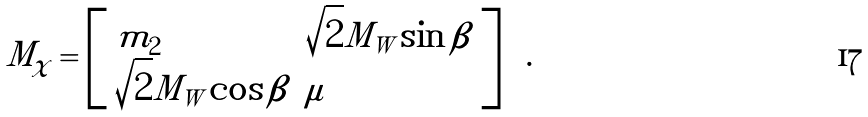<formula> <loc_0><loc_0><loc_500><loc_500>M _ { \chi } = \left [ \begin{array} { l l } { { { m } _ { 2 } } } & { { \sqrt { 2 } M _ { W } \sin \beta } } \\ { { \sqrt { 2 } M _ { W } \cos \beta } } & { \mu } \end{array} \right ] \ \ .</formula> 